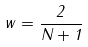Convert formula to latex. <formula><loc_0><loc_0><loc_500><loc_500>w = \frac { 2 } { N + 1 }</formula> 